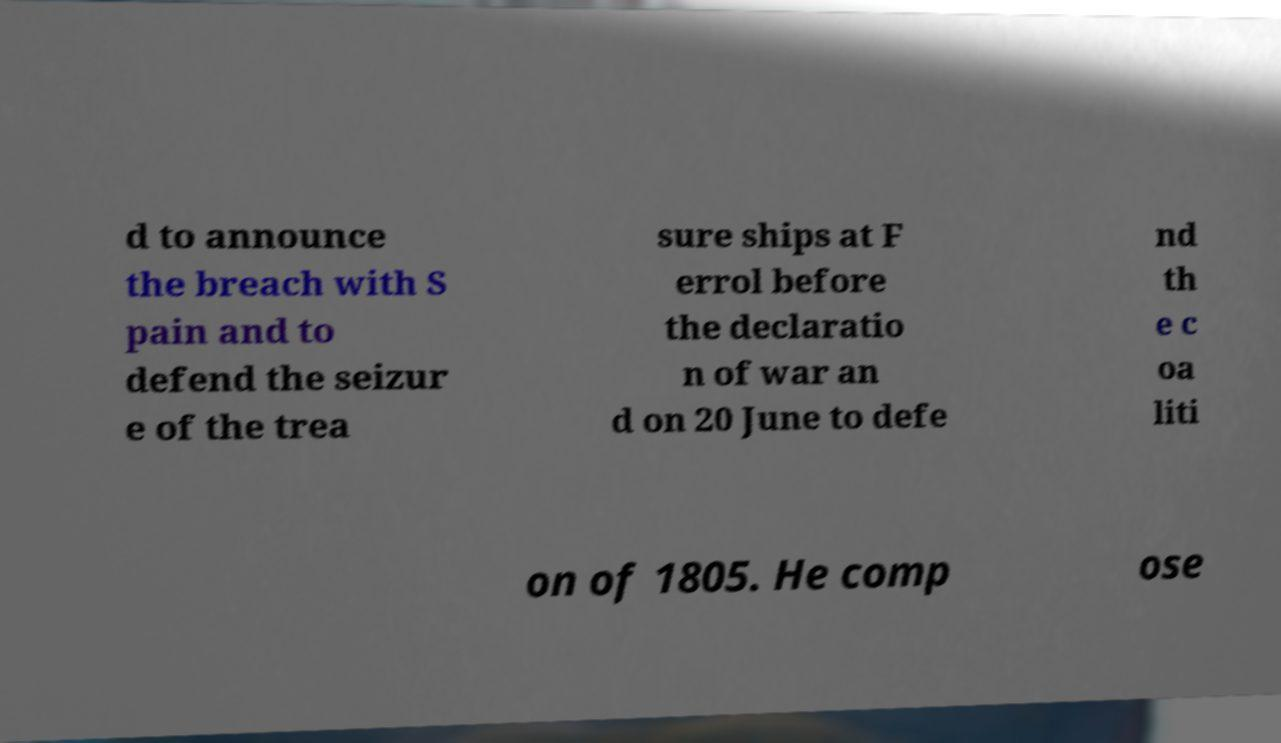Can you accurately transcribe the text from the provided image for me? d to announce the breach with S pain and to defend the seizur e of the trea sure ships at F errol before the declaratio n of war an d on 20 June to defe nd th e c oa liti on of 1805. He comp ose 